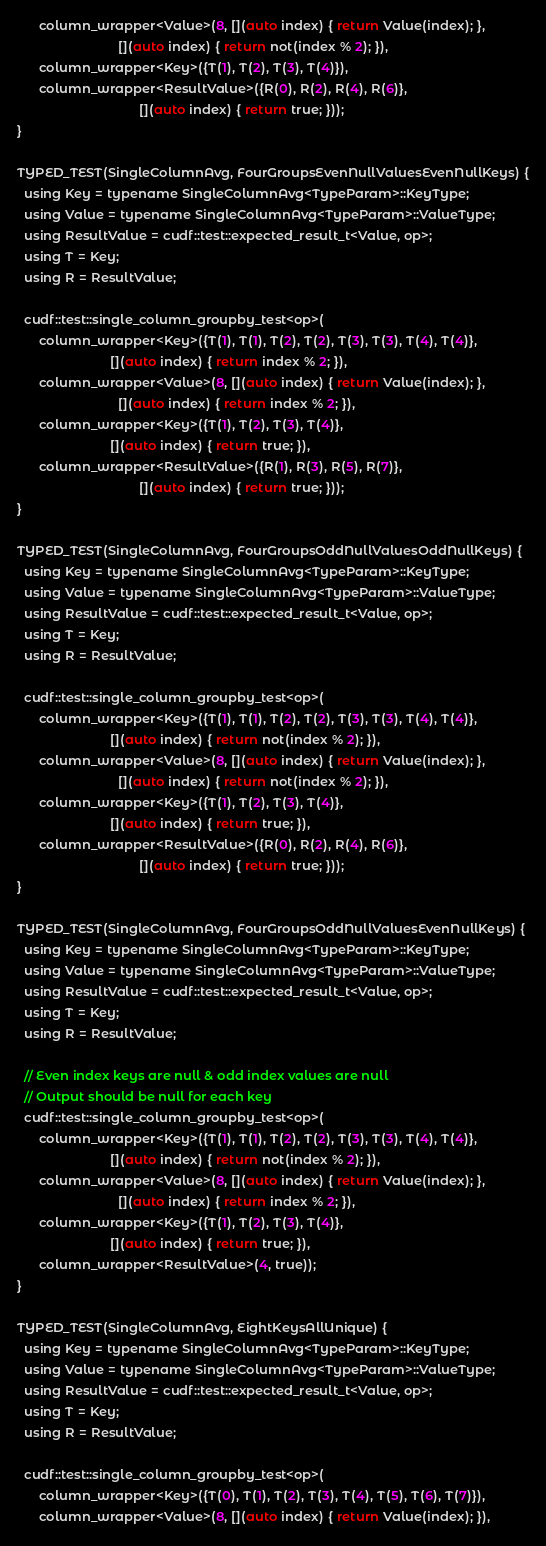<code> <loc_0><loc_0><loc_500><loc_500><_Cuda_>      column_wrapper<Value>(8, [](auto index) { return Value(index); },
                            [](auto index) { return not(index % 2); }),
      column_wrapper<Key>({T(1), T(2), T(3), T(4)}),
      column_wrapper<ResultValue>({R(0), R(2), R(4), R(6)},
                                  [](auto index) { return true; }));
}

TYPED_TEST(SingleColumnAvg, FourGroupsEvenNullValuesEvenNullKeys) {
  using Key = typename SingleColumnAvg<TypeParam>::KeyType;
  using Value = typename SingleColumnAvg<TypeParam>::ValueType;
  using ResultValue = cudf::test::expected_result_t<Value, op>;
  using T = Key;
  using R = ResultValue;

  cudf::test::single_column_groupby_test<op>(
      column_wrapper<Key>({T(1), T(1), T(2), T(2), T(3), T(3), T(4), T(4)},
                          [](auto index) { return index % 2; }),
      column_wrapper<Value>(8, [](auto index) { return Value(index); },
                            [](auto index) { return index % 2; }),
      column_wrapper<Key>({T(1), T(2), T(3), T(4)},
                          [](auto index) { return true; }),
      column_wrapper<ResultValue>({R(1), R(3), R(5), R(7)},
                                  [](auto index) { return true; }));
}

TYPED_TEST(SingleColumnAvg, FourGroupsOddNullValuesOddNullKeys) {
  using Key = typename SingleColumnAvg<TypeParam>::KeyType;
  using Value = typename SingleColumnAvg<TypeParam>::ValueType;
  using ResultValue = cudf::test::expected_result_t<Value, op>;
  using T = Key;
  using R = ResultValue;

  cudf::test::single_column_groupby_test<op>(
      column_wrapper<Key>({T(1), T(1), T(2), T(2), T(3), T(3), T(4), T(4)},
                          [](auto index) { return not(index % 2); }),
      column_wrapper<Value>(8, [](auto index) { return Value(index); },
                            [](auto index) { return not(index % 2); }),
      column_wrapper<Key>({T(1), T(2), T(3), T(4)},
                          [](auto index) { return true; }),
      column_wrapper<ResultValue>({R(0), R(2), R(4), R(6)},
                                  [](auto index) { return true; }));
}

TYPED_TEST(SingleColumnAvg, FourGroupsOddNullValuesEvenNullKeys) {
  using Key = typename SingleColumnAvg<TypeParam>::KeyType;
  using Value = typename SingleColumnAvg<TypeParam>::ValueType;
  using ResultValue = cudf::test::expected_result_t<Value, op>;
  using T = Key;
  using R = ResultValue;

  // Even index keys are null & odd index values are null
  // Output should be null for each key
  cudf::test::single_column_groupby_test<op>(
      column_wrapper<Key>({T(1), T(1), T(2), T(2), T(3), T(3), T(4), T(4)},
                          [](auto index) { return not(index % 2); }),
      column_wrapper<Value>(8, [](auto index) { return Value(index); },
                            [](auto index) { return index % 2; }),
      column_wrapper<Key>({T(1), T(2), T(3), T(4)},
                          [](auto index) { return true; }),
      column_wrapper<ResultValue>(4, true));
}

TYPED_TEST(SingleColumnAvg, EightKeysAllUnique) {
  using Key = typename SingleColumnAvg<TypeParam>::KeyType;
  using Value = typename SingleColumnAvg<TypeParam>::ValueType;
  using ResultValue = cudf::test::expected_result_t<Value, op>;
  using T = Key;
  using R = ResultValue;

  cudf::test::single_column_groupby_test<op>(
      column_wrapper<Key>({T(0), T(1), T(2), T(3), T(4), T(5), T(6), T(7)}),
      column_wrapper<Value>(8, [](auto index) { return Value(index); }),</code> 